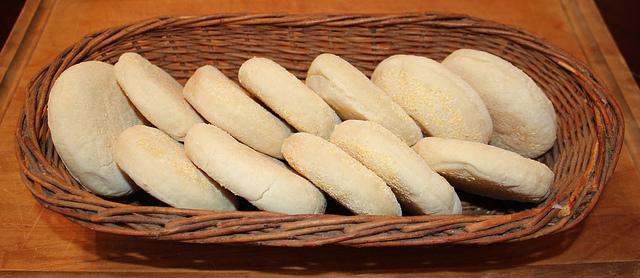What kind of food is this?
Quick response, please. Bread. Are these cookies?
Write a very short answer. No. How many buns are in the basket?
Answer briefly. 12. 